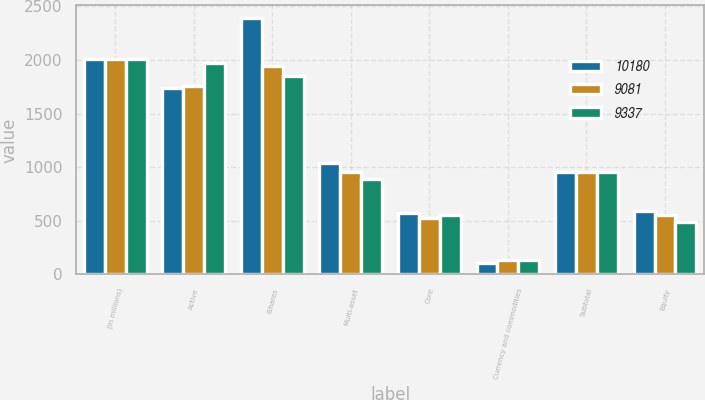Convert chart. <chart><loc_0><loc_0><loc_500><loc_500><stacked_bar_chart><ecel><fcel>(in millions)<fcel>Active<fcel>iShares<fcel>Multi-asset<fcel>Core<fcel>Currency and commodities<fcel>Subtotal<fcel>Equity<nl><fcel>10180<fcel>2013<fcel>1741<fcel>2390<fcel>1039<fcel>576<fcel>107<fcel>957<fcel>594<nl><fcel>9081<fcel>2012<fcel>1753<fcel>1941<fcel>957<fcel>525<fcel>131<fcel>957<fcel>552<nl><fcel>9337<fcel>2011<fcel>1967<fcel>1847<fcel>894<fcel>557<fcel>136<fcel>957<fcel>488<nl></chart> 